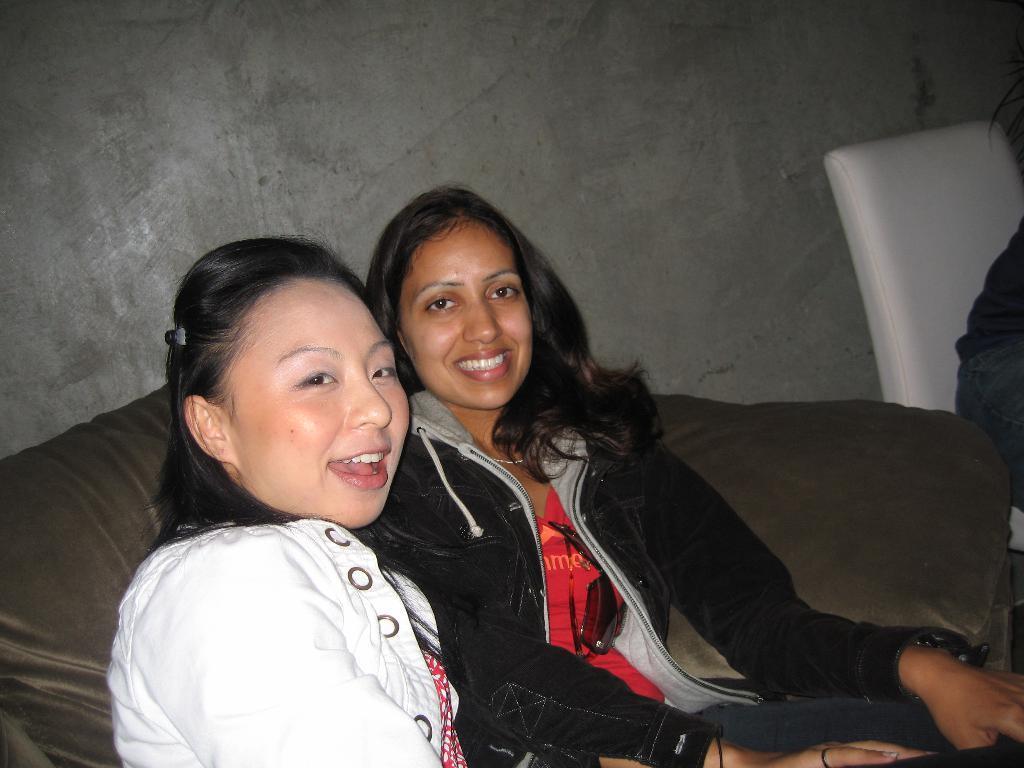Can you describe this image briefly? In this image there are two women sitting in a sofa with a smile on their face, beside them there is another person in the chair. 